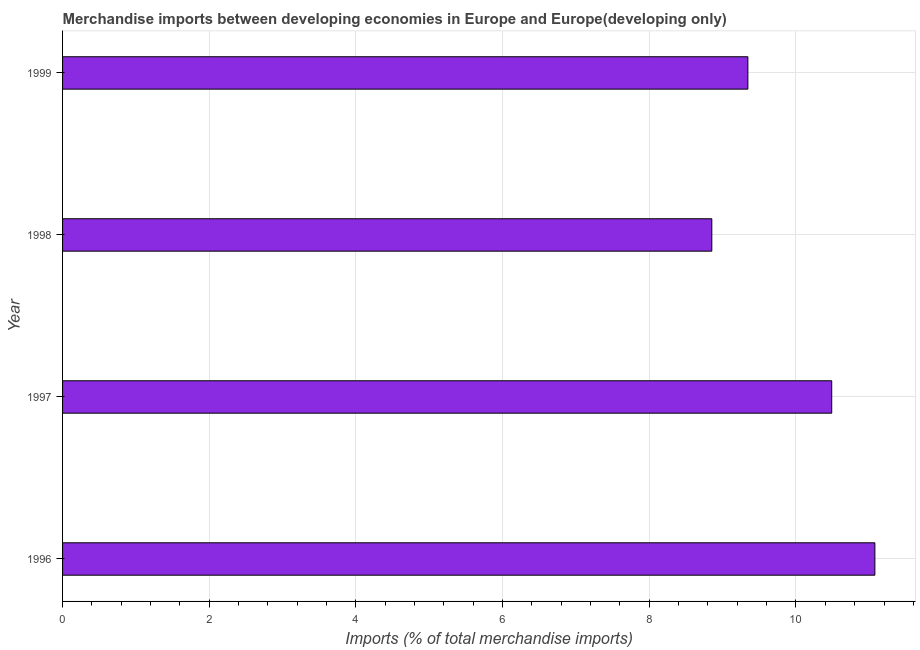Does the graph contain any zero values?
Provide a short and direct response. No. What is the title of the graph?
Provide a short and direct response. Merchandise imports between developing economies in Europe and Europe(developing only). What is the label or title of the X-axis?
Make the answer very short. Imports (% of total merchandise imports). What is the merchandise imports in 1996?
Give a very brief answer. 11.08. Across all years, what is the maximum merchandise imports?
Offer a terse response. 11.08. Across all years, what is the minimum merchandise imports?
Keep it short and to the point. 8.85. In which year was the merchandise imports maximum?
Your response must be concise. 1996. What is the sum of the merchandise imports?
Provide a succinct answer. 39.76. What is the difference between the merchandise imports in 1997 and 1998?
Ensure brevity in your answer.  1.64. What is the average merchandise imports per year?
Provide a succinct answer. 9.94. What is the median merchandise imports?
Keep it short and to the point. 9.92. In how many years, is the merchandise imports greater than 10 %?
Your response must be concise. 2. What is the ratio of the merchandise imports in 1996 to that in 1997?
Offer a terse response. 1.06. What is the difference between the highest and the second highest merchandise imports?
Your response must be concise. 0.59. Is the sum of the merchandise imports in 1996 and 1997 greater than the maximum merchandise imports across all years?
Your answer should be compact. Yes. What is the difference between the highest and the lowest merchandise imports?
Offer a very short reply. 2.22. How many bars are there?
Your answer should be compact. 4. How many years are there in the graph?
Make the answer very short. 4. Are the values on the major ticks of X-axis written in scientific E-notation?
Ensure brevity in your answer.  No. What is the Imports (% of total merchandise imports) in 1996?
Your response must be concise. 11.08. What is the Imports (% of total merchandise imports) in 1997?
Make the answer very short. 10.49. What is the Imports (% of total merchandise imports) of 1998?
Provide a short and direct response. 8.85. What is the Imports (% of total merchandise imports) in 1999?
Keep it short and to the point. 9.34. What is the difference between the Imports (% of total merchandise imports) in 1996 and 1997?
Provide a short and direct response. 0.59. What is the difference between the Imports (% of total merchandise imports) in 1996 and 1998?
Your answer should be compact. 2.22. What is the difference between the Imports (% of total merchandise imports) in 1996 and 1999?
Your response must be concise. 1.73. What is the difference between the Imports (% of total merchandise imports) in 1997 and 1998?
Make the answer very short. 1.64. What is the difference between the Imports (% of total merchandise imports) in 1997 and 1999?
Ensure brevity in your answer.  1.14. What is the difference between the Imports (% of total merchandise imports) in 1998 and 1999?
Keep it short and to the point. -0.49. What is the ratio of the Imports (% of total merchandise imports) in 1996 to that in 1997?
Your response must be concise. 1.06. What is the ratio of the Imports (% of total merchandise imports) in 1996 to that in 1998?
Your answer should be very brief. 1.25. What is the ratio of the Imports (% of total merchandise imports) in 1996 to that in 1999?
Provide a succinct answer. 1.19. What is the ratio of the Imports (% of total merchandise imports) in 1997 to that in 1998?
Provide a short and direct response. 1.19. What is the ratio of the Imports (% of total merchandise imports) in 1997 to that in 1999?
Offer a terse response. 1.12. What is the ratio of the Imports (% of total merchandise imports) in 1998 to that in 1999?
Keep it short and to the point. 0.95. 